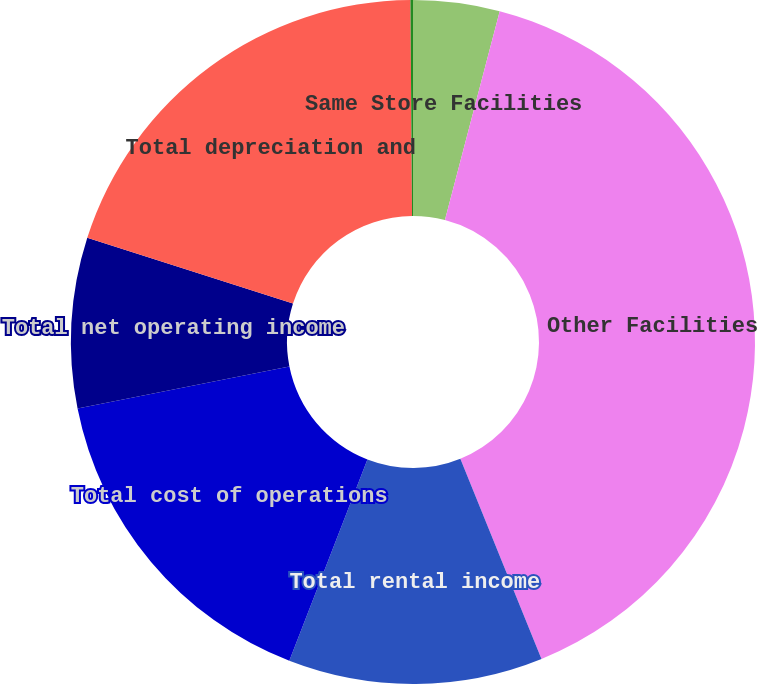Convert chart to OTSL. <chart><loc_0><loc_0><loc_500><loc_500><pie_chart><fcel>Same Store Facilities<fcel>Other Facilities<fcel>Total rental income<fcel>Total cost of operations<fcel>Total net operating income<fcel>Total depreciation and<fcel>Total net income<nl><fcel>4.08%<fcel>39.79%<fcel>12.02%<fcel>15.99%<fcel>8.05%<fcel>19.95%<fcel>0.12%<nl></chart> 